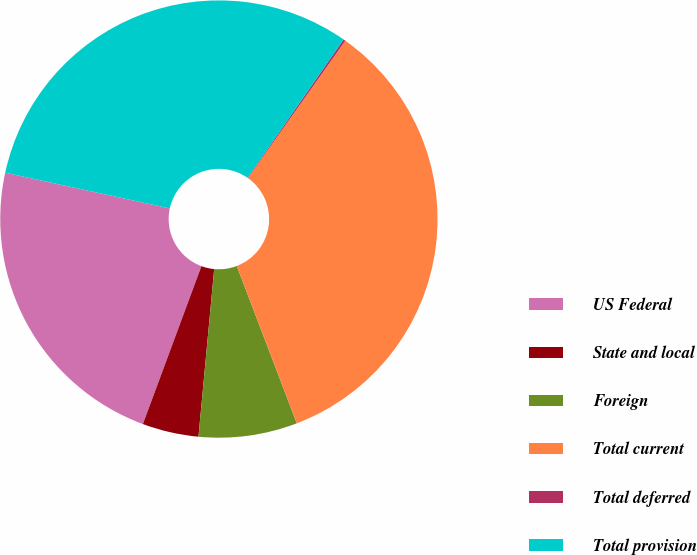<chart> <loc_0><loc_0><loc_500><loc_500><pie_chart><fcel>US Federal<fcel>State and local<fcel>Foreign<fcel>Total current<fcel>Total deferred<fcel>Total provision<nl><fcel>22.75%<fcel>4.16%<fcel>7.29%<fcel>34.38%<fcel>0.16%<fcel>31.26%<nl></chart> 